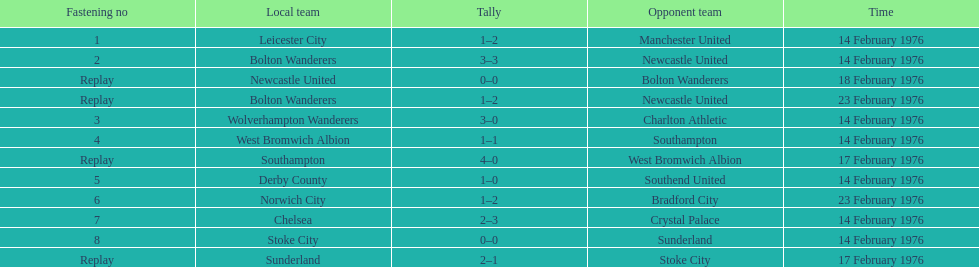How many of these games occurred before 17 february 1976? 7. 